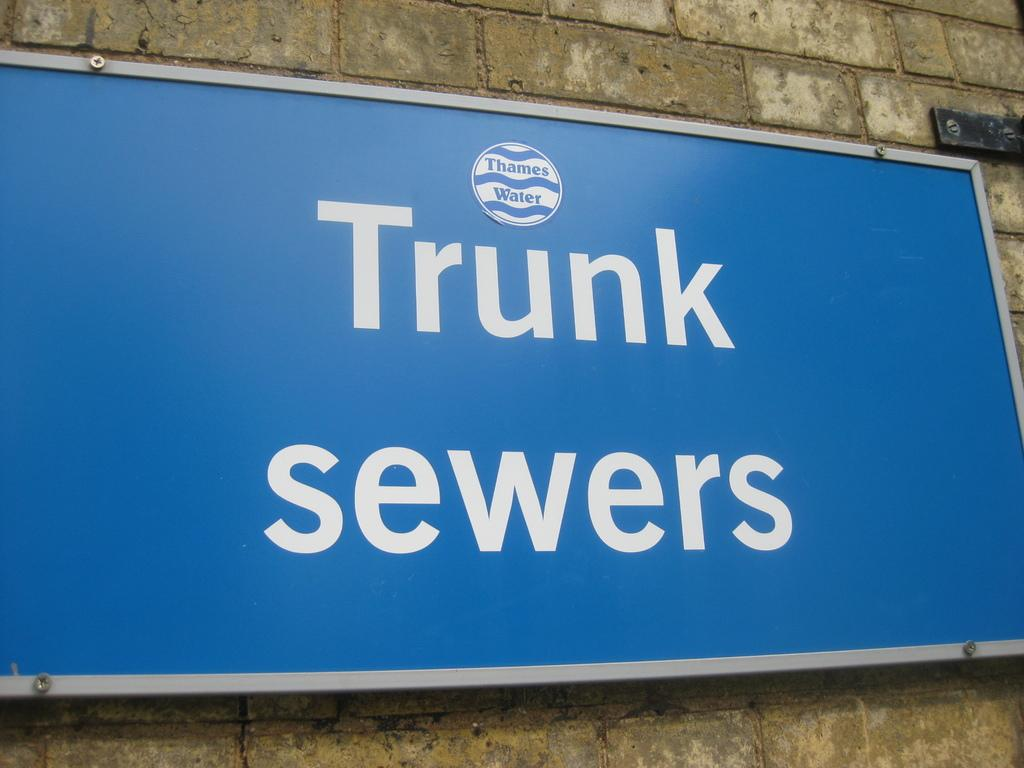Provide a one-sentence caption for the provided image. A sign in white letters that reads Trunk Sewers hangs on the site of a wall. 